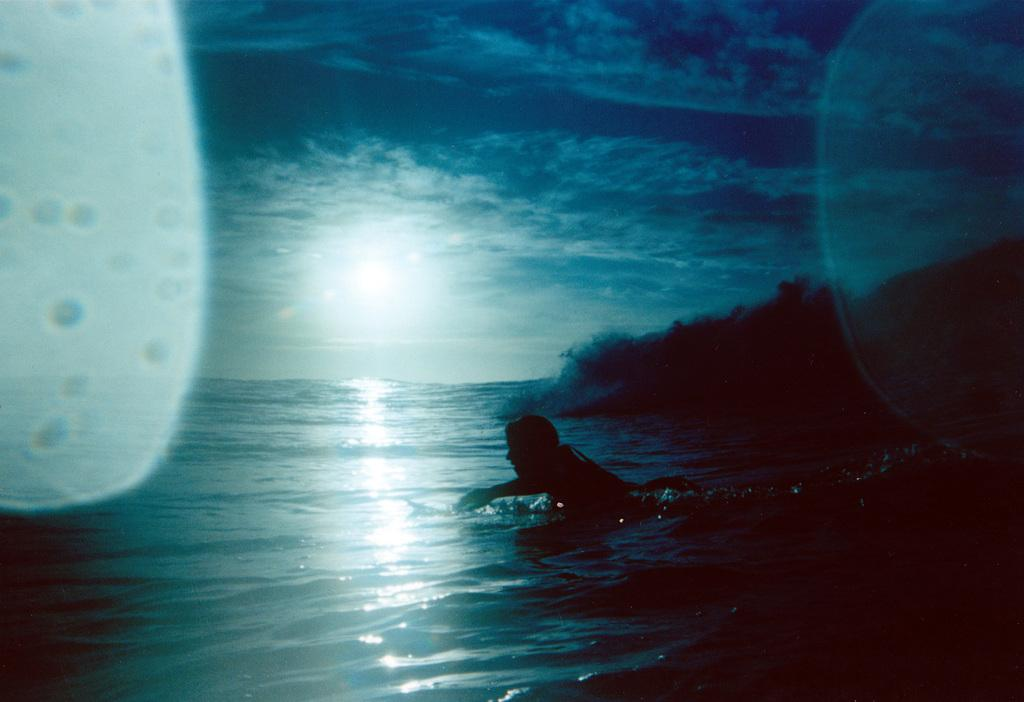What is the person in the image doing? There is a person swimming in the water in the image. What can be seen on the right side of the image? There are trees on the land on the right side of the image. What is visible at the top of the image? The sky is visible at the top of the image. What can be observed in the sky? Clouds and the sun are present in the sky. What type of notebook is the person using to swim in the image? There is no notebook present in the image, and the person is swimming without any notebook. Can you see any dinosaurs in the image? No, there are no dinosaurs present in the image. 